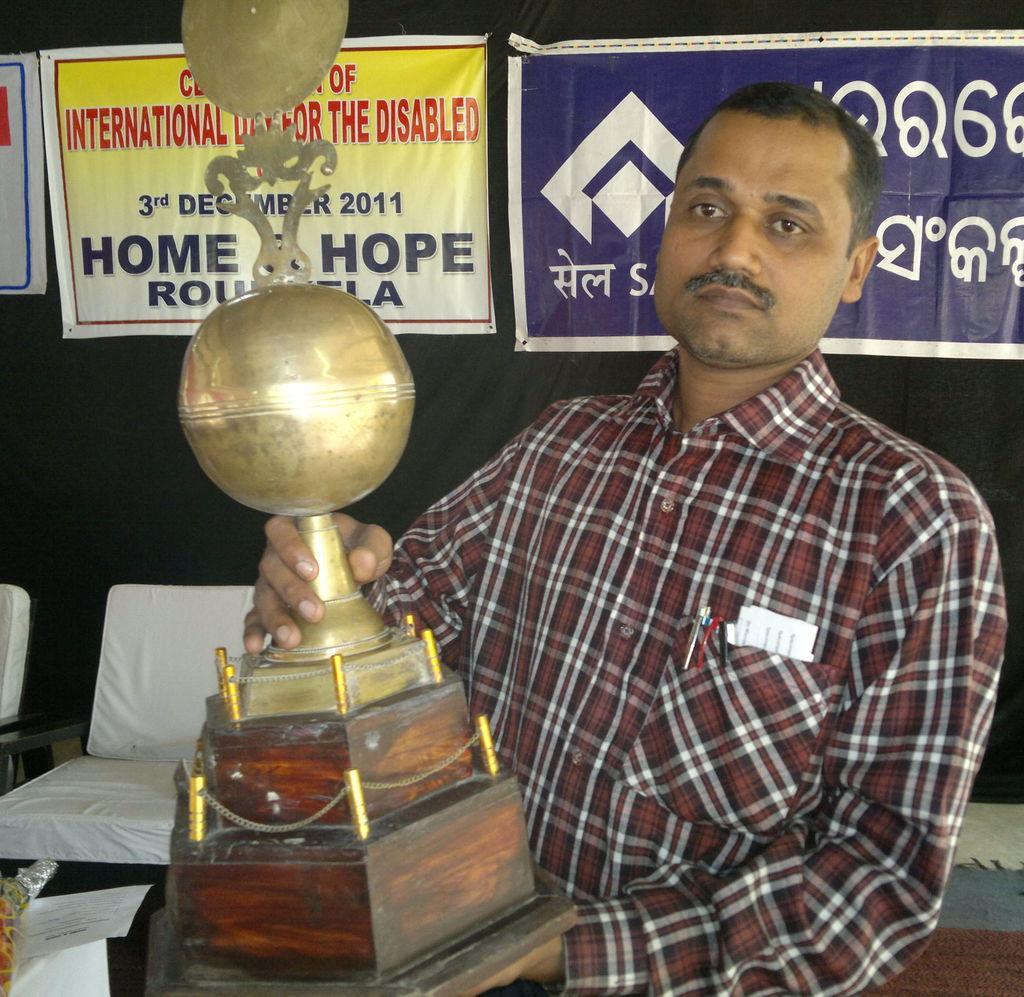Could you give a brief overview of what you see in this image? In this image we can see a man holding a trophy. In the back there are chairs. Also there is a wall with banners. On the banners there is text. 